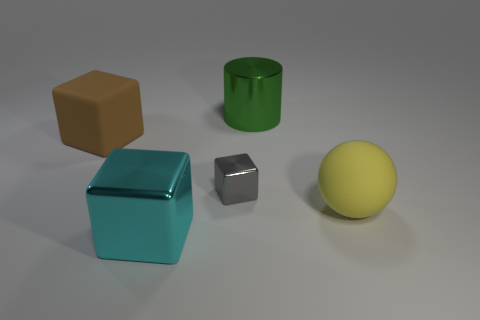What shape is the large brown thing in front of the large green shiny cylinder?
Give a very brief answer. Cube. Is there a big cyan thing that is behind the cube that is to the left of the big metal thing that is in front of the big yellow object?
Offer a terse response. No. Is there any other thing that is the same shape as the yellow thing?
Your answer should be very brief. No. Are any rubber things visible?
Your answer should be compact. Yes. Are the green cylinder to the right of the tiny gray object and the yellow object that is in front of the large rubber block made of the same material?
Your answer should be very brief. No. There is a rubber thing behind the tiny metal object that is to the right of the large brown matte object to the left of the matte sphere; what size is it?
Your response must be concise. Large. How many other brown blocks have the same material as the big brown block?
Give a very brief answer. 0. Is the number of cyan things less than the number of large cubes?
Offer a terse response. Yes. What size is the gray shiny thing that is the same shape as the brown rubber thing?
Offer a terse response. Small. Do the object that is on the right side of the big green cylinder and the green object have the same material?
Make the answer very short. No. 